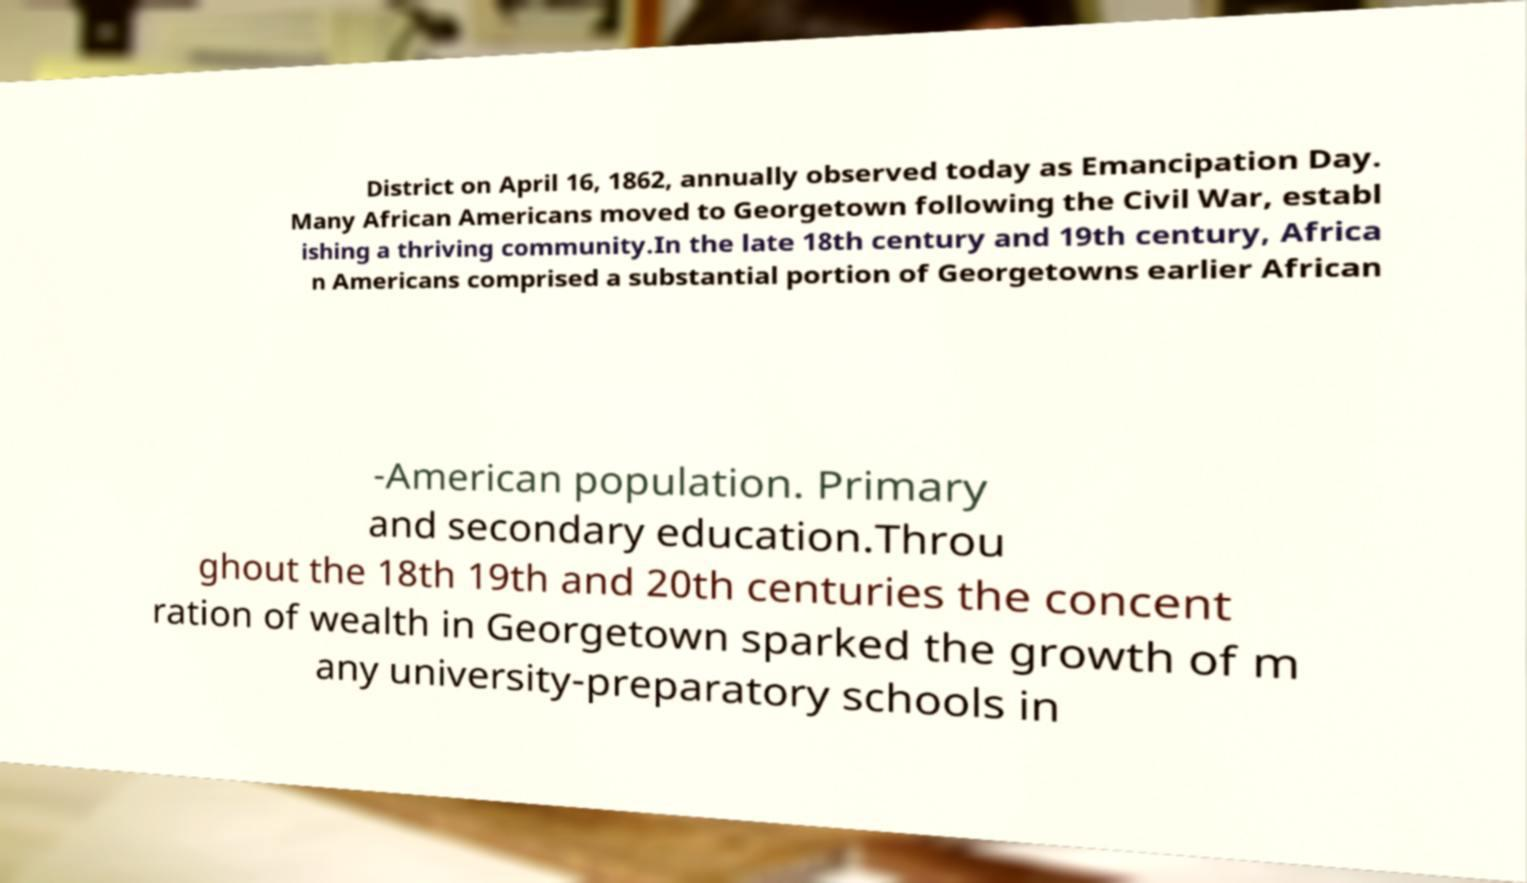Please identify and transcribe the text found in this image. District on April 16, 1862, annually observed today as Emancipation Day. Many African Americans moved to Georgetown following the Civil War, establ ishing a thriving community.In the late 18th century and 19th century, Africa n Americans comprised a substantial portion of Georgetowns earlier African -American population. Primary and secondary education.Throu ghout the 18th 19th and 20th centuries the concent ration of wealth in Georgetown sparked the growth of m any university-preparatory schools in 